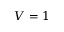Convert formula to latex. <formula><loc_0><loc_0><loc_500><loc_500>V = 1</formula> 